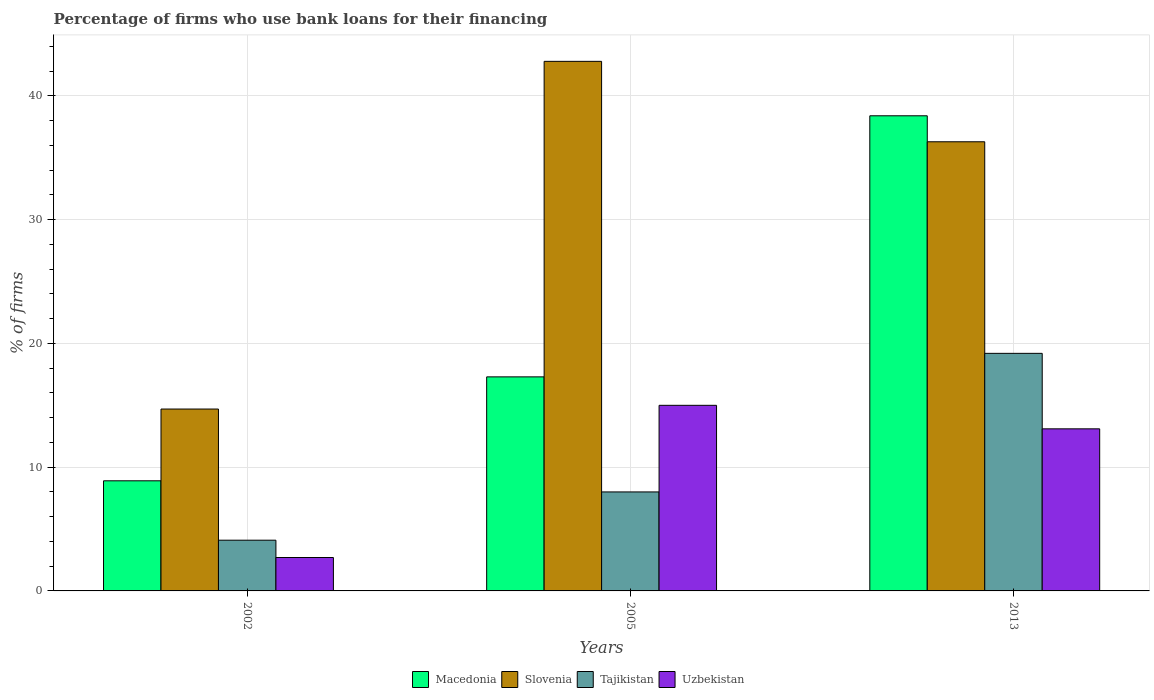How many different coloured bars are there?
Your answer should be very brief. 4. How many groups of bars are there?
Offer a very short reply. 3. How many bars are there on the 1st tick from the right?
Offer a very short reply. 4. What is the percentage of firms who use bank loans for their financing in Tajikistan in 2005?
Give a very brief answer. 8. Across all years, what is the maximum percentage of firms who use bank loans for their financing in Macedonia?
Offer a very short reply. 38.4. Across all years, what is the minimum percentage of firms who use bank loans for their financing in Macedonia?
Provide a succinct answer. 8.9. What is the total percentage of firms who use bank loans for their financing in Slovenia in the graph?
Provide a short and direct response. 93.8. What is the difference between the percentage of firms who use bank loans for their financing in Tajikistan in 2005 and the percentage of firms who use bank loans for their financing in Uzbekistan in 2002?
Provide a short and direct response. 5.3. What is the average percentage of firms who use bank loans for their financing in Tajikistan per year?
Ensure brevity in your answer.  10.43. In the year 2002, what is the difference between the percentage of firms who use bank loans for their financing in Uzbekistan and percentage of firms who use bank loans for their financing in Macedonia?
Your answer should be compact. -6.2. What is the ratio of the percentage of firms who use bank loans for their financing in Macedonia in 2002 to that in 2013?
Offer a very short reply. 0.23. Is the percentage of firms who use bank loans for their financing in Macedonia in 2002 less than that in 2013?
Provide a succinct answer. Yes. Is the difference between the percentage of firms who use bank loans for their financing in Uzbekistan in 2002 and 2005 greater than the difference between the percentage of firms who use bank loans for their financing in Macedonia in 2002 and 2005?
Your answer should be compact. No. What is the difference between the highest and the second highest percentage of firms who use bank loans for their financing in Uzbekistan?
Offer a terse response. 1.9. Is it the case that in every year, the sum of the percentage of firms who use bank loans for their financing in Tajikistan and percentage of firms who use bank loans for their financing in Slovenia is greater than the sum of percentage of firms who use bank loans for their financing in Macedonia and percentage of firms who use bank loans for their financing in Uzbekistan?
Your response must be concise. No. What does the 4th bar from the left in 2005 represents?
Offer a terse response. Uzbekistan. What does the 1st bar from the right in 2005 represents?
Keep it short and to the point. Uzbekistan. How many bars are there?
Provide a succinct answer. 12. Are all the bars in the graph horizontal?
Your answer should be very brief. No. How many years are there in the graph?
Your response must be concise. 3. How many legend labels are there?
Your response must be concise. 4. How are the legend labels stacked?
Ensure brevity in your answer.  Horizontal. What is the title of the graph?
Give a very brief answer. Percentage of firms who use bank loans for their financing. What is the label or title of the Y-axis?
Make the answer very short. % of firms. What is the % of firms in Macedonia in 2005?
Give a very brief answer. 17.3. What is the % of firms of Slovenia in 2005?
Your answer should be very brief. 42.8. What is the % of firms in Uzbekistan in 2005?
Give a very brief answer. 15. What is the % of firms of Macedonia in 2013?
Offer a very short reply. 38.4. What is the % of firms of Slovenia in 2013?
Offer a very short reply. 36.3. What is the % of firms in Uzbekistan in 2013?
Offer a terse response. 13.1. Across all years, what is the maximum % of firms of Macedonia?
Your answer should be compact. 38.4. Across all years, what is the maximum % of firms in Slovenia?
Keep it short and to the point. 42.8. Across all years, what is the minimum % of firms of Tajikistan?
Keep it short and to the point. 4.1. Across all years, what is the minimum % of firms in Uzbekistan?
Offer a very short reply. 2.7. What is the total % of firms of Macedonia in the graph?
Your answer should be compact. 64.6. What is the total % of firms in Slovenia in the graph?
Ensure brevity in your answer.  93.8. What is the total % of firms in Tajikistan in the graph?
Offer a very short reply. 31.3. What is the total % of firms of Uzbekistan in the graph?
Keep it short and to the point. 30.8. What is the difference between the % of firms in Slovenia in 2002 and that in 2005?
Your response must be concise. -28.1. What is the difference between the % of firms of Tajikistan in 2002 and that in 2005?
Offer a terse response. -3.9. What is the difference between the % of firms in Uzbekistan in 2002 and that in 2005?
Make the answer very short. -12.3. What is the difference between the % of firms of Macedonia in 2002 and that in 2013?
Make the answer very short. -29.5. What is the difference between the % of firms of Slovenia in 2002 and that in 2013?
Provide a short and direct response. -21.6. What is the difference between the % of firms of Tajikistan in 2002 and that in 2013?
Offer a terse response. -15.1. What is the difference between the % of firms in Macedonia in 2005 and that in 2013?
Your answer should be compact. -21.1. What is the difference between the % of firms in Tajikistan in 2005 and that in 2013?
Provide a succinct answer. -11.2. What is the difference between the % of firms in Macedonia in 2002 and the % of firms in Slovenia in 2005?
Provide a short and direct response. -33.9. What is the difference between the % of firms of Macedonia in 2002 and the % of firms of Tajikistan in 2005?
Your answer should be compact. 0.9. What is the difference between the % of firms in Tajikistan in 2002 and the % of firms in Uzbekistan in 2005?
Keep it short and to the point. -10.9. What is the difference between the % of firms of Macedonia in 2002 and the % of firms of Slovenia in 2013?
Your answer should be very brief. -27.4. What is the difference between the % of firms of Macedonia in 2002 and the % of firms of Uzbekistan in 2013?
Make the answer very short. -4.2. What is the difference between the % of firms in Slovenia in 2002 and the % of firms in Tajikistan in 2013?
Your answer should be very brief. -4.5. What is the difference between the % of firms of Tajikistan in 2002 and the % of firms of Uzbekistan in 2013?
Give a very brief answer. -9. What is the difference between the % of firms of Macedonia in 2005 and the % of firms of Slovenia in 2013?
Offer a terse response. -19. What is the difference between the % of firms in Slovenia in 2005 and the % of firms in Tajikistan in 2013?
Give a very brief answer. 23.6. What is the difference between the % of firms of Slovenia in 2005 and the % of firms of Uzbekistan in 2013?
Keep it short and to the point. 29.7. What is the difference between the % of firms of Tajikistan in 2005 and the % of firms of Uzbekistan in 2013?
Your answer should be very brief. -5.1. What is the average % of firms in Macedonia per year?
Offer a terse response. 21.53. What is the average % of firms in Slovenia per year?
Ensure brevity in your answer.  31.27. What is the average % of firms in Tajikistan per year?
Your answer should be compact. 10.43. What is the average % of firms of Uzbekistan per year?
Provide a succinct answer. 10.27. In the year 2002, what is the difference between the % of firms in Macedonia and % of firms in Uzbekistan?
Offer a very short reply. 6.2. In the year 2002, what is the difference between the % of firms in Tajikistan and % of firms in Uzbekistan?
Make the answer very short. 1.4. In the year 2005, what is the difference between the % of firms in Macedonia and % of firms in Slovenia?
Keep it short and to the point. -25.5. In the year 2005, what is the difference between the % of firms in Macedonia and % of firms in Tajikistan?
Your response must be concise. 9.3. In the year 2005, what is the difference between the % of firms in Macedonia and % of firms in Uzbekistan?
Your answer should be compact. 2.3. In the year 2005, what is the difference between the % of firms of Slovenia and % of firms of Tajikistan?
Offer a terse response. 34.8. In the year 2005, what is the difference between the % of firms in Slovenia and % of firms in Uzbekistan?
Make the answer very short. 27.8. In the year 2005, what is the difference between the % of firms of Tajikistan and % of firms of Uzbekistan?
Provide a succinct answer. -7. In the year 2013, what is the difference between the % of firms in Macedonia and % of firms in Tajikistan?
Offer a terse response. 19.2. In the year 2013, what is the difference between the % of firms in Macedonia and % of firms in Uzbekistan?
Offer a terse response. 25.3. In the year 2013, what is the difference between the % of firms of Slovenia and % of firms of Uzbekistan?
Offer a very short reply. 23.2. What is the ratio of the % of firms in Macedonia in 2002 to that in 2005?
Keep it short and to the point. 0.51. What is the ratio of the % of firms in Slovenia in 2002 to that in 2005?
Keep it short and to the point. 0.34. What is the ratio of the % of firms of Tajikistan in 2002 to that in 2005?
Your response must be concise. 0.51. What is the ratio of the % of firms of Uzbekistan in 2002 to that in 2005?
Your response must be concise. 0.18. What is the ratio of the % of firms of Macedonia in 2002 to that in 2013?
Your response must be concise. 0.23. What is the ratio of the % of firms of Slovenia in 2002 to that in 2013?
Offer a very short reply. 0.41. What is the ratio of the % of firms in Tajikistan in 2002 to that in 2013?
Your answer should be very brief. 0.21. What is the ratio of the % of firms of Uzbekistan in 2002 to that in 2013?
Your response must be concise. 0.21. What is the ratio of the % of firms of Macedonia in 2005 to that in 2013?
Provide a succinct answer. 0.45. What is the ratio of the % of firms in Slovenia in 2005 to that in 2013?
Offer a very short reply. 1.18. What is the ratio of the % of firms of Tajikistan in 2005 to that in 2013?
Your response must be concise. 0.42. What is the ratio of the % of firms in Uzbekistan in 2005 to that in 2013?
Make the answer very short. 1.15. What is the difference between the highest and the second highest % of firms in Macedonia?
Give a very brief answer. 21.1. What is the difference between the highest and the second highest % of firms of Uzbekistan?
Your answer should be compact. 1.9. What is the difference between the highest and the lowest % of firms of Macedonia?
Your response must be concise. 29.5. What is the difference between the highest and the lowest % of firms of Slovenia?
Your response must be concise. 28.1. What is the difference between the highest and the lowest % of firms in Tajikistan?
Provide a short and direct response. 15.1. 